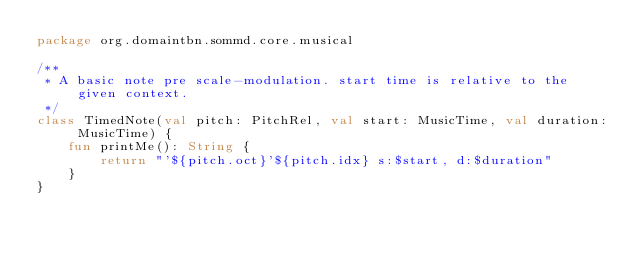<code> <loc_0><loc_0><loc_500><loc_500><_Kotlin_>package org.domaintbn.sommd.core.musical

/**
 * A basic note pre scale-modulation. start time is relative to the given context.
 */
class TimedNote(val pitch: PitchRel, val start: MusicTime, val duration: MusicTime) {
    fun printMe(): String {
        return "'${pitch.oct}'${pitch.idx} s:$start, d:$duration"
    }
}</code> 